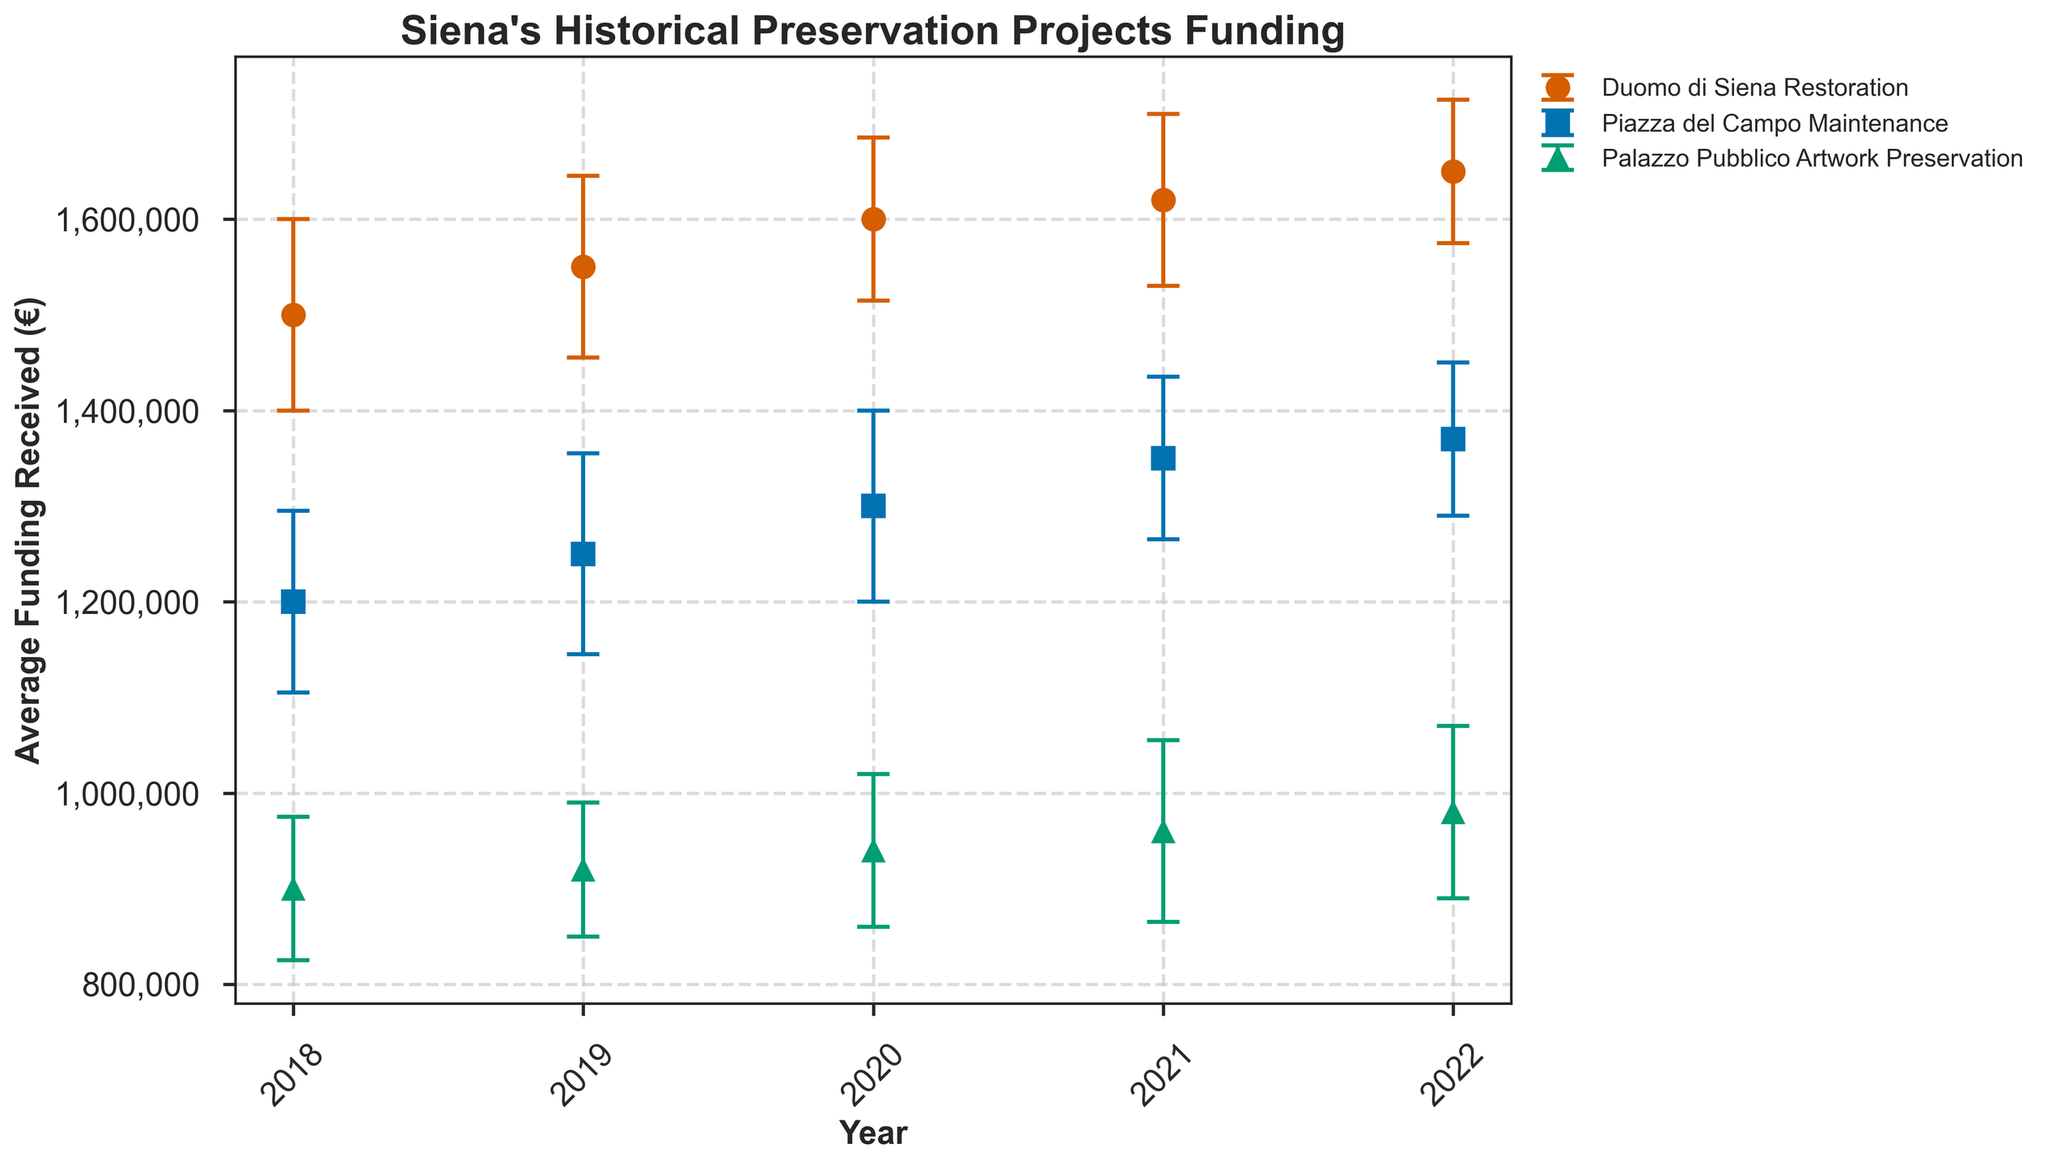What is the title of the plot? The title of the plot is typically found at the top of the chart. For this figure, it is clearly stated as "Siena's Historical Preservation Projects Funding."
Answer: Siena's Historical Preservation Projects Funding What does the x-axis represent? The label underneath the horizontal axis indicates what it represents. In this case, it is marked as "Year."
Answer: Year Which project received the highest average funding in 2022? To find this, look for the highest point on the y-axis for the year 2022. The "Duomo di Siena Restoration" project has the highest point at €1,650,000.
Answer: Duomo di Siena Restoration How did the average funding for the Palazzo Pubblico Artwork Preservation project change from 2018 to 2022? Track the data points for the "Palazzo Pubblico Artwork Preservation" project across the years from 2018 to 2022. Calculate the differences year by year, then sum up these values to find the overall change. Funding increased from €900,000 in 2018 to €980,000 in 2022, an increase of €80,000.
Answer: Increased by €80,000 Which year saw the smallest variation in funding for the Duomo di Siena Restoration project? Locate the error bars for the "Duomo di Siena Restoration" project and identify the year with the shortest error bar. In this case, 2022 has the smallest variation at €75,000.
Answer: 2022 How does the funding variation in 2020 for the Piazza del Campo Maintenance project compare to its variation in 2018? Compare the lengths of the error bars for the "Piazza del Campo Maintenance" project for the years 2020 (€100,000) and 2018 (€95,000). The variation in 2020 is €5,000 higher than in 2018.
Answer: 2020 variation is €5,000 higher What is the total average funding received by all projects in 2021? Add the average funding of all three projects for the year 2021: €1,620,000 (Duomo di Siena Restoration) + €1,350,000 (Piazza del Campo Maintenance) + €960,000 (Palazzo Pubblico Artwork Preservation). The total is €3,930,000.
Answer: €3,930,000 Which project had the highest increase in average funding from 2018 to 2022? Calculate the increase in average funding for each project from 2018 to 2022 and identify the greatest increase. Duomo di Siena Restoration increased from €1,500,000 to €1,650,000 (an increase of €150,000).
Answer: Duomo di Siena Restoration Between 2019 and 2020, which project saw the largest increase in average funding? Compute the difference in average funding for each project between 2019 and 2020. The "Duomo di Siena Restoration" saw an increase from €1,550,000 to €1,600,000, an increase of €50,000. This is the largest when compared to other projects.
Answer: Duomo di Siena Restoration In which year did the Piazza del Campo Maintenance project receive its highest average funding? Look across the years on the horizontal axis and identify when the "Piazza del Campo Maintenance" project had the highest funding point. The highest is €1,370,000 in 2022.
Answer: 2022 